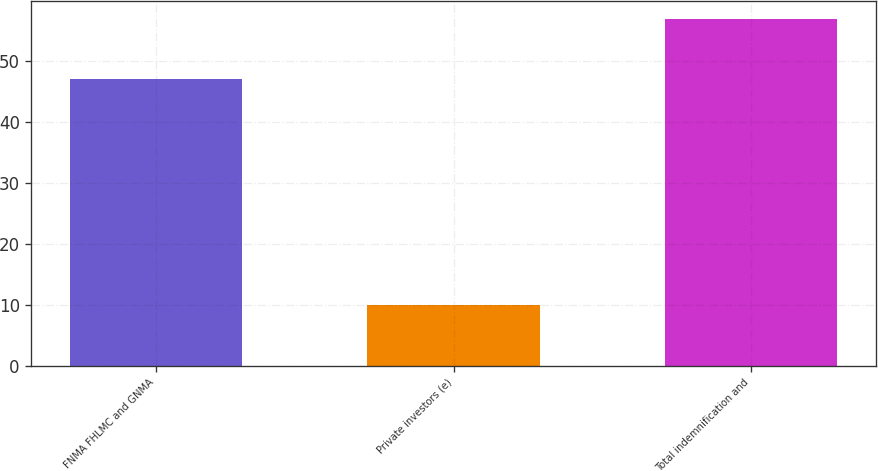Convert chart to OTSL. <chart><loc_0><loc_0><loc_500><loc_500><bar_chart><fcel>FNMA FHLMC and GNMA<fcel>Private investors (e)<fcel>Total indemnification and<nl><fcel>47<fcel>10<fcel>57<nl></chart> 